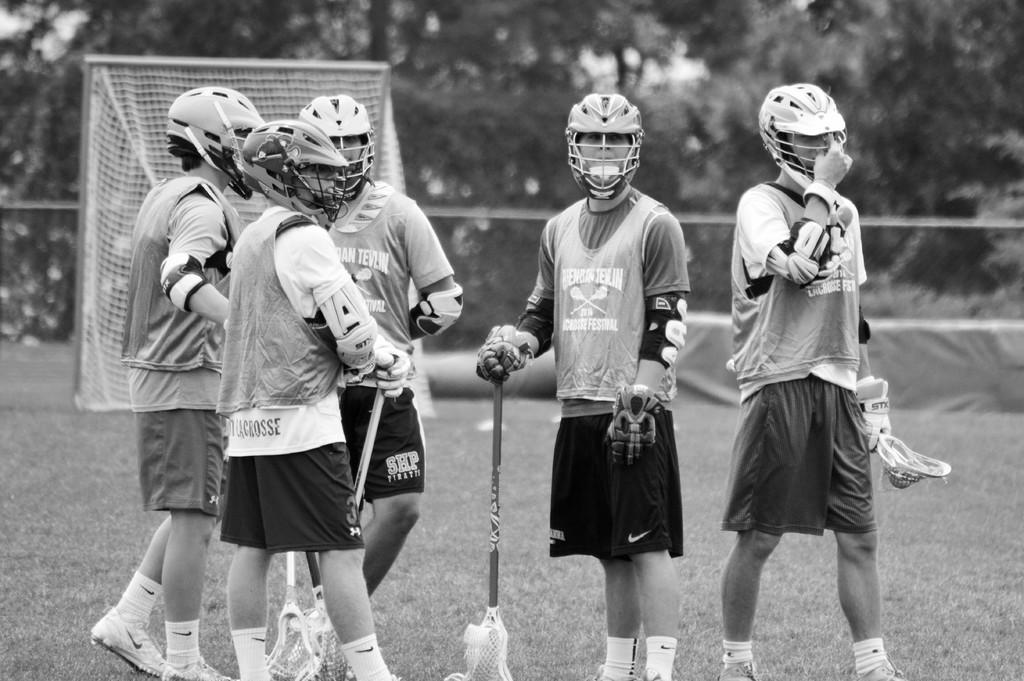What is the color scheme of the image? The image is black and white. What type of terrain can be seen in the image? There are players standing on the grassy land in the image. What is present in the background of the image? There is a net, a fence, and trees in the background of the image. Can you see any yaks grazing on the grass in the image? No, there are no yaks present in the image. What type of trade is being conducted in the image? There is no trade being conducted in the image; it features players standing on grassy land with a net and trees in the background. 